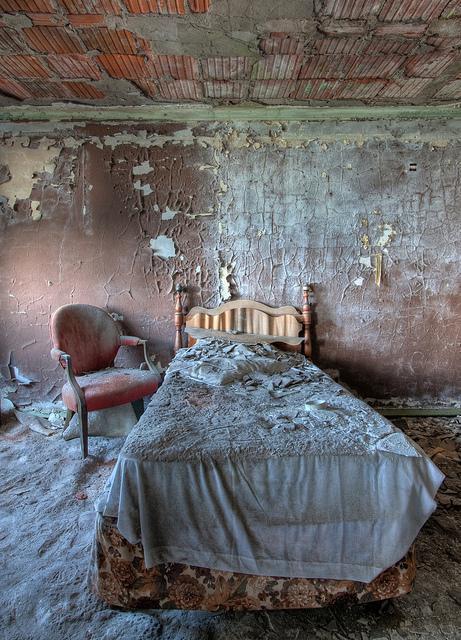How many train cars are orange?
Give a very brief answer. 0. 